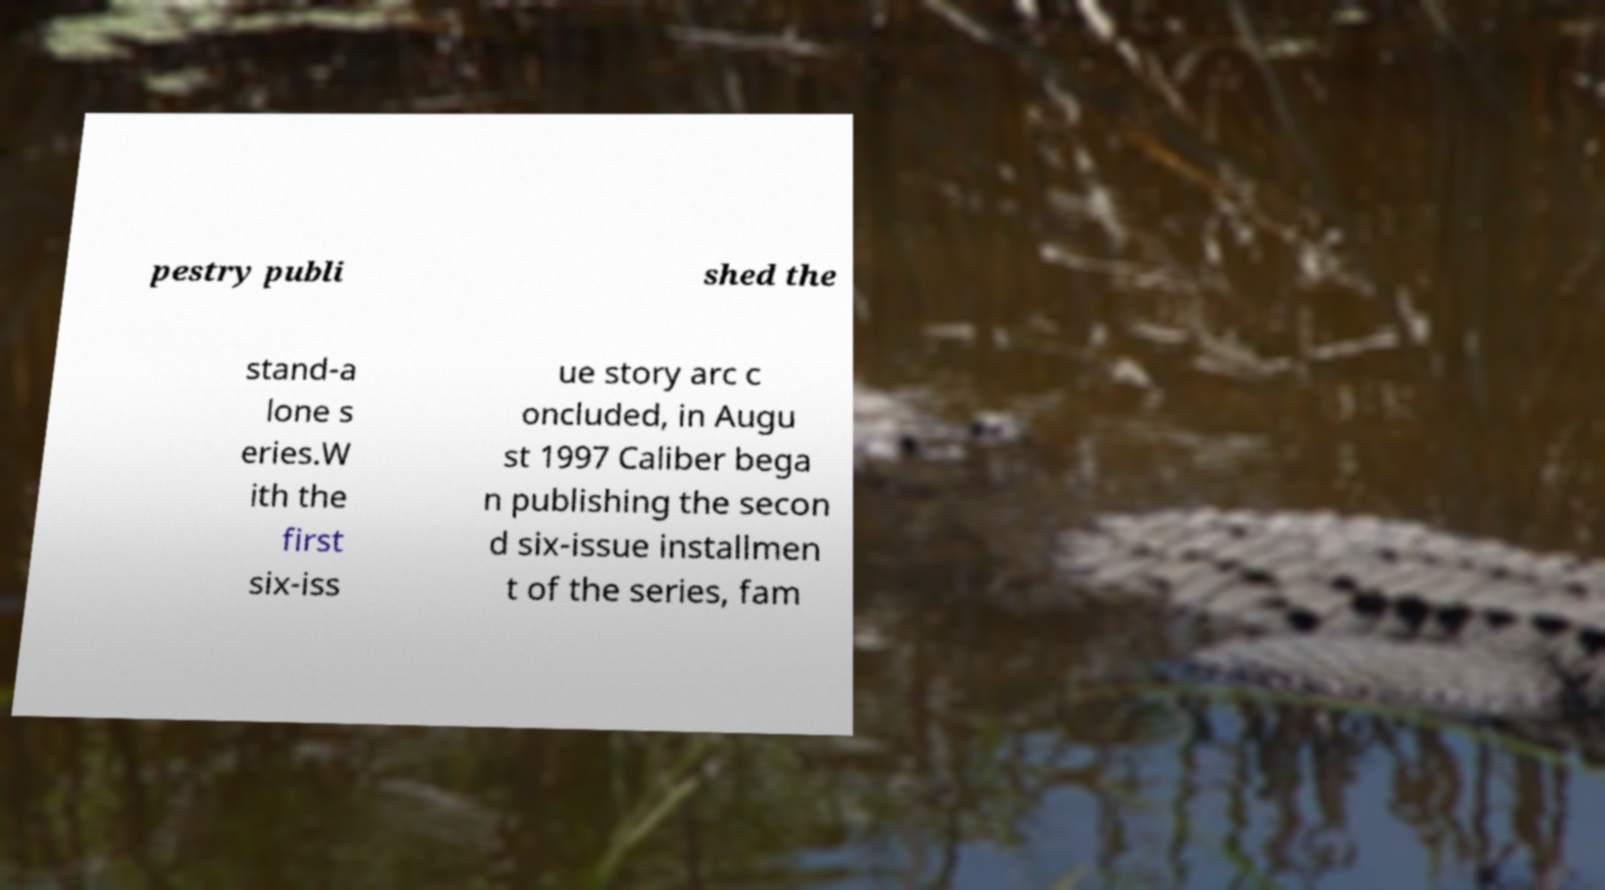Can you accurately transcribe the text from the provided image for me? pestry publi shed the stand-a lone s eries.W ith the first six-iss ue story arc c oncluded, in Augu st 1997 Caliber bega n publishing the secon d six-issue installmen t of the series, fam 